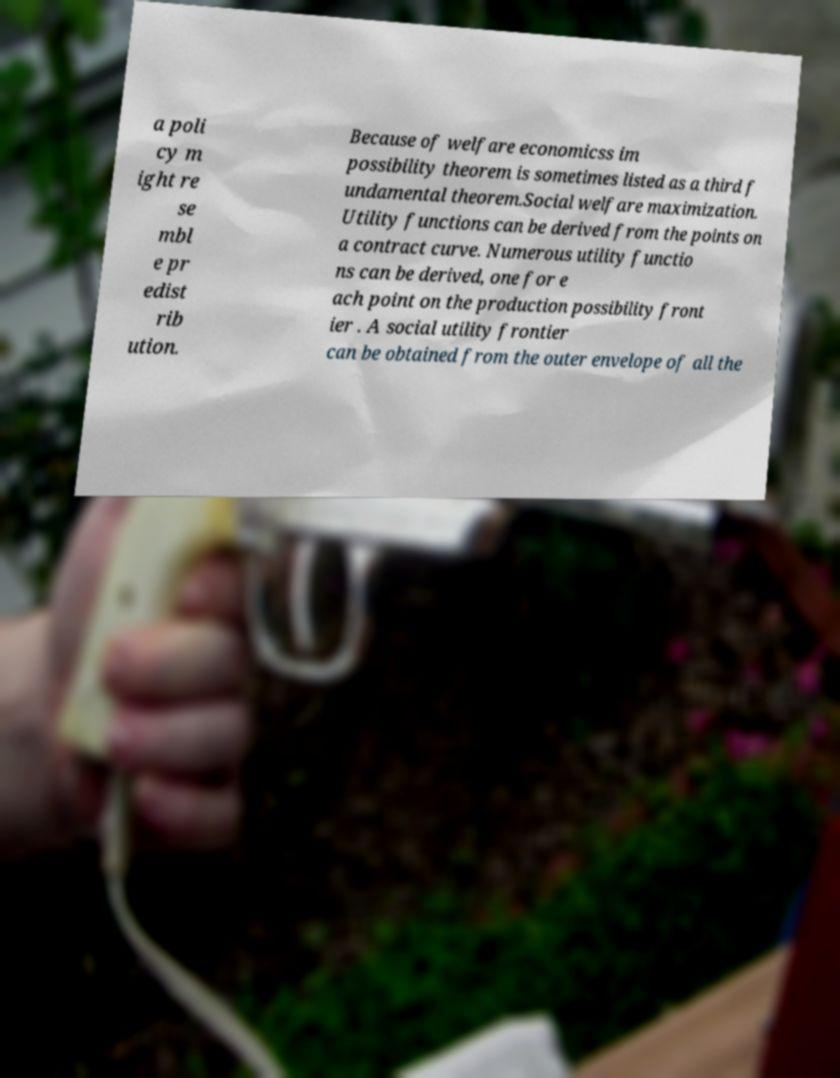What messages or text are displayed in this image? I need them in a readable, typed format. a poli cy m ight re se mbl e pr edist rib ution. Because of welfare economicss im possibility theorem is sometimes listed as a third f undamental theorem.Social welfare maximization. Utility functions can be derived from the points on a contract curve. Numerous utility functio ns can be derived, one for e ach point on the production possibility front ier . A social utility frontier can be obtained from the outer envelope of all the 